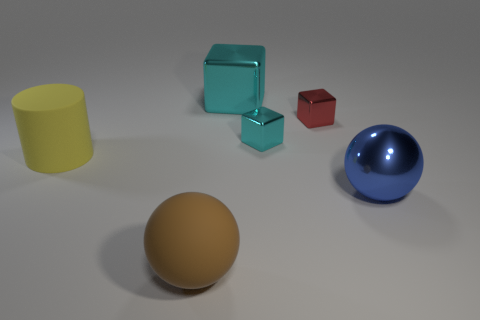Subtract all red cylinders. How many cyan blocks are left? 2 Subtract all tiny cubes. How many cubes are left? 1 Add 1 big brown rubber balls. How many objects exist? 7 Subtract all blue shiny spheres. Subtract all red metallic objects. How many objects are left? 4 Add 5 big objects. How many big objects are left? 9 Add 6 shiny spheres. How many shiny spheres exist? 7 Subtract 0 yellow spheres. How many objects are left? 6 Subtract all balls. How many objects are left? 4 